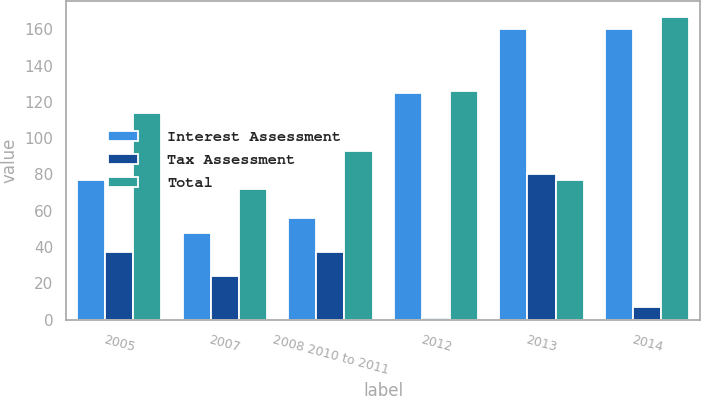Convert chart to OTSL. <chart><loc_0><loc_0><loc_500><loc_500><stacked_bar_chart><ecel><fcel>2005<fcel>2007<fcel>2008 2010 to 2011<fcel>2012<fcel>2013<fcel>2014<nl><fcel>Interest Assessment<fcel>77<fcel>48<fcel>56<fcel>125<fcel>160<fcel>160<nl><fcel>Tax Assessment<fcel>37<fcel>24<fcel>37<fcel>1<fcel>80<fcel>7<nl><fcel>Total<fcel>114<fcel>72<fcel>93<fcel>126<fcel>77<fcel>167<nl></chart> 